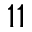Convert formula to latex. <formula><loc_0><loc_0><loc_500><loc_500>1 1</formula> 